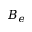Convert formula to latex. <formula><loc_0><loc_0><loc_500><loc_500>B _ { e }</formula> 